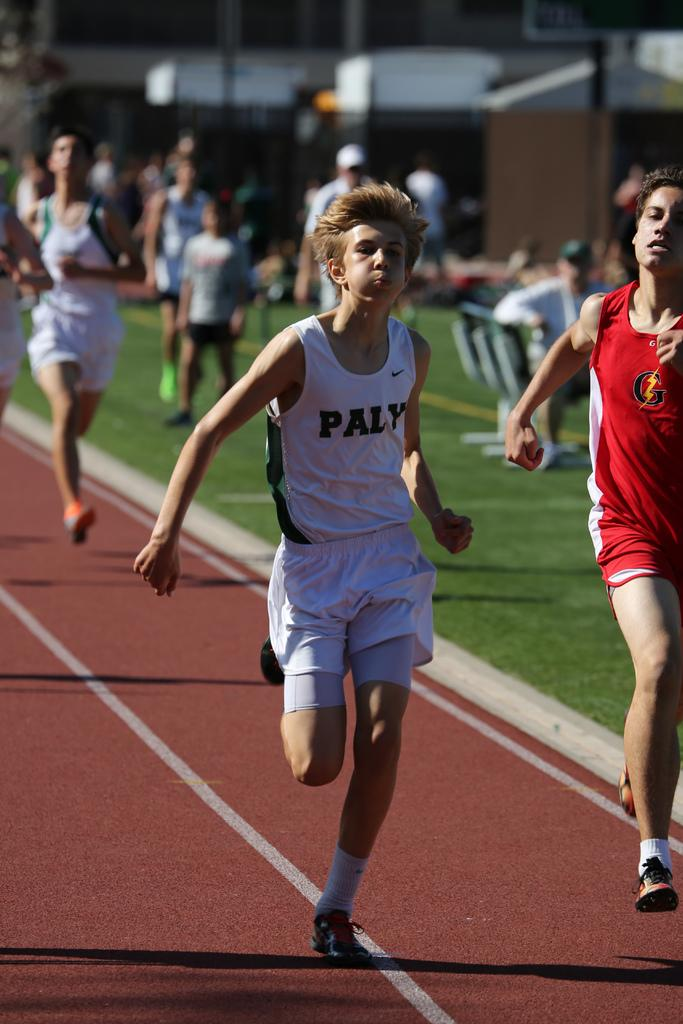What are the people in the image doing? There are people running on the ground in the image. Can you describe the people in the background of the image? There are people standing in the background of the image. What structure is visible at the top of the image? There is a building at the top of the image. How many seats are available for lunch in the image? There is no mention of lunch or seats in the image; it features people running and standing, as well as a building. 